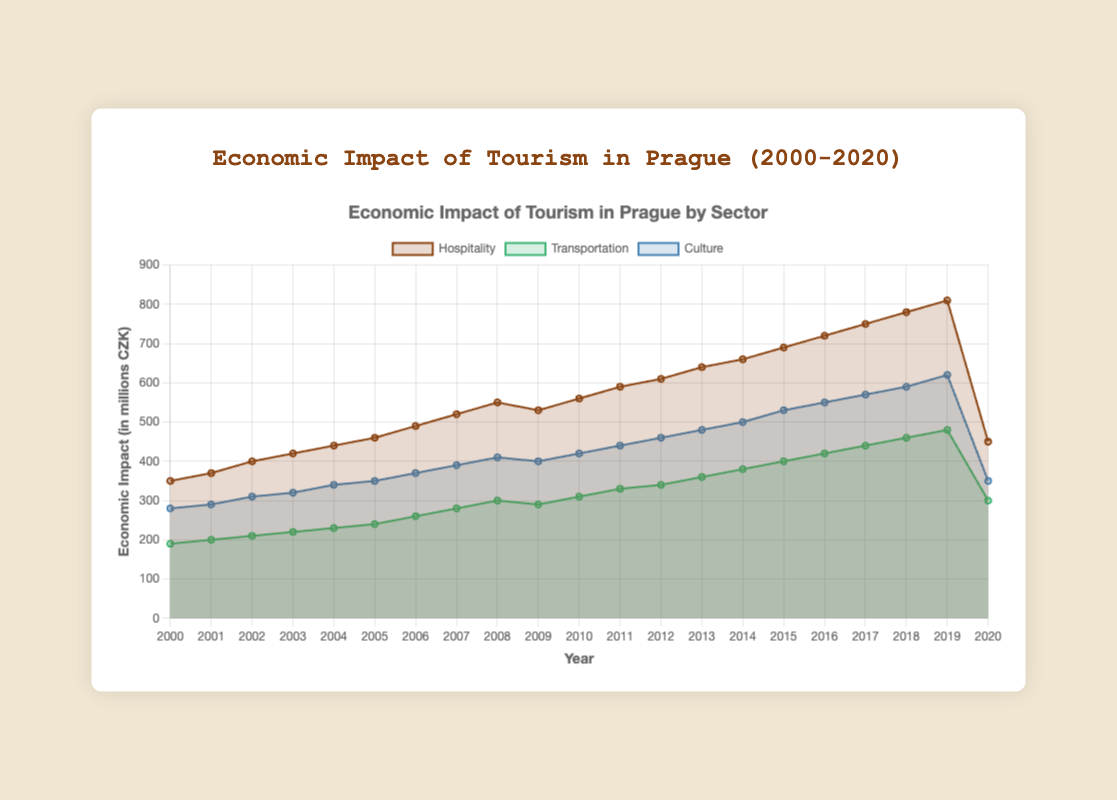What is the title of the figure? The title appears at the top of the figure and reads "Economic Impact of Tourism in Prague (2000-2020)".
Answer: Economic Impact of Tourism in Prague (2000-2020) Which sector had the highest economic impact in 2019? Compare the values for all sectors in the year 2019. Hospitality shows 810 million CZK, Transportation shows 480 million CZK, and Culture shows 620 million CZK. Hence, Hospitality had the highest economic impact.
Answer: Hospitality How much did the economic impact in the hospitality sector change from 2019 to 2020? Subtract the value in 2020 (450) from the value in 2019 (810) for the Hospitality sector. 810 - 450 = 360 million CZK.
Answer: 360 million CZK What is the average economic impact of the transportation sector over the given years? Sum all the values for the Transportation sector and divide by the number of years (21). (190 + 200 + 210 + 220 + 230 + 240 + 260 + 280 + 300 + 290 + 310 + 330 + 340 + 360 + 380 + 400 + 420 + 440 + 460 + 480 + 300) / 21 = 3270 / 21 = 155.71 million CZK.
Answer: 155.71 million CZK What is the trend observed in the economic impact of the culture sector from 2000 to 2013? Observe the plotted line for the Culture sector from 2000 to 2013. The values show a consistent increase from 280 in 2000 to 480 in 2013.
Answer: Increasing trend How did the economic impact of tourism in Prague change across all sectors during the global financial crisis around 2008-2009? Compare the economic impact in 2008 and 2009 for all sectors. Hospitality decreased from 550 to 530, Transportation decreased from 300 to 290, and Culture decreased from 410 to 400. The economic impact in all sectors decreased.
Answer: Decreased Which sector experienced the steepest drop in economic impact in 2020? Compare the change in values from 2019 to 2020 across all sectors. Hospitality drops from 810 to 450 (a decrease of 360), Transportation from 480 to 300 (a decrease of 180), and Culture from 620 to 350 (a decrease of 270). The Hospitality sector experienced the steepest drop.
Answer: Hospitality Calculate the total economic impact of tourism in Prague in 2010 across all sectors. Add the economic impacts of Hospitality (560), Transportation (310), and Culture (420) in the year 2010. 560 + 310 + 420 = 1290 million CZK.
Answer: 1290 million CZK Which sector showed the most consistent growth from 2000 to 2020? Check the trends for all sectors over the years. The Hospitality sector shows a consistent growth line except for minor dips. Transportation and Culture also show consistent growth but had slight variations compared to the Hospitality sector.
Answer: Hospitality What is the difference in economic impact between the highest-earning sector and the lowest-earning sector in 2005? Compare the values in 2005. Hospitality (460), Transportation (240), and Culture (350). The difference between the highest (Hospitality) and lowest (Transportation) is 460 - 240 = 220 million CZK.
Answer: 220 million CZK 